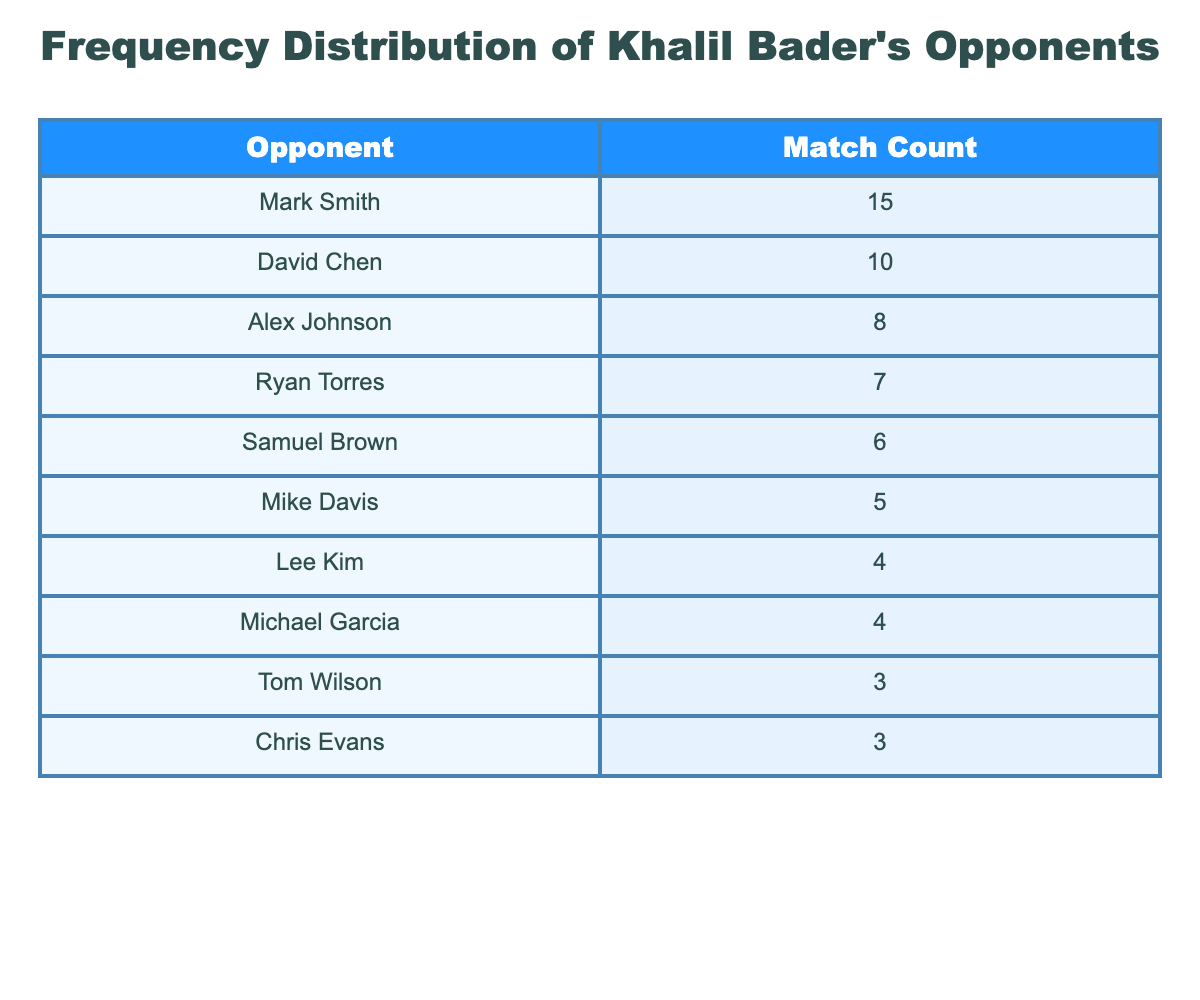What is the most common opponent Khalil Bader faced? According to the table, Mark Smith has the highest match count of 15, making him the most common opponent faced by Khalil Bader.
Answer: Mark Smith How many matches did Khalil Bader play against Ryan Torres? The table shows that Ryan Torres is listed with a match count of 7, indicating the number of matches he has faced against Khalil Bader.
Answer: 7 What is the total number of matches Khalil Bader has faced against all listed opponents? To find the total, add all the match counts: 15 + 10 + 8 + 7 + 6 + 5 + 4 + 4 + 3 + 3 = 65. Therefore, Khalil Bader has faced a total of 65 matches against the opponents listed.
Answer: 65 Are there more opponents Khalil faced at least 5 times or less than 5 times? The table shows there are 6 opponents with match counts of 5 or more (Mark Smith, David Chen, Alex Johnson, Ryan Torres, Samuel Brown, Mike Davis) and 4 opponents with less than 5 matches (Lee Kim, Michael Garcia, Tom Wilson, Chris Evans). Thus, there are more opponents faced at least 5 times.
Answer: Yes What is the average number of matches faced against the opponents listed in the table? To find the average, we first sum the match counts (65 as calculated previously) and divide by the number of opponents (10): 65 / 10 = 6.5. Thus, the average number of matches faced against these opponents is 6.5.
Answer: 6.5 Which opponent has the least number of matches faced by Khalil Bader? From the table, the opponents with the least matches are Tom Wilson and Chris Evans, both with a match count of 3. They are tied for the least number of matches faced.
Answer: Tom Wilson and Chris Evans What number of matches did Khalil play against Samuel Brown compared to Alex Johnson? Samuel Brown faced Khalil Bader 6 times, while Alex Johnson faced him 8 times. We can see Alex Johnson has 2 more matches than Samuel Brown.
Answer: Alex Johnson has 2 more matches How many opponents did Khalil Bader face more than 6 times? The table indicates 4 opponents faced within the range of more than 6 times: Mark Smith (15), David Chen (10), Alex Johnson (8), and Ryan Torres (7). Therefore, 4 opponents were faced more than 6 times.
Answer: 4 